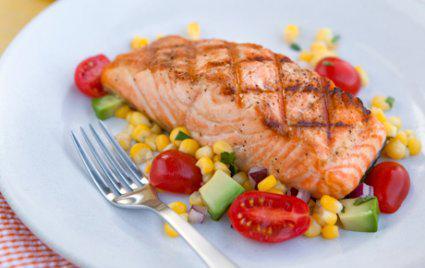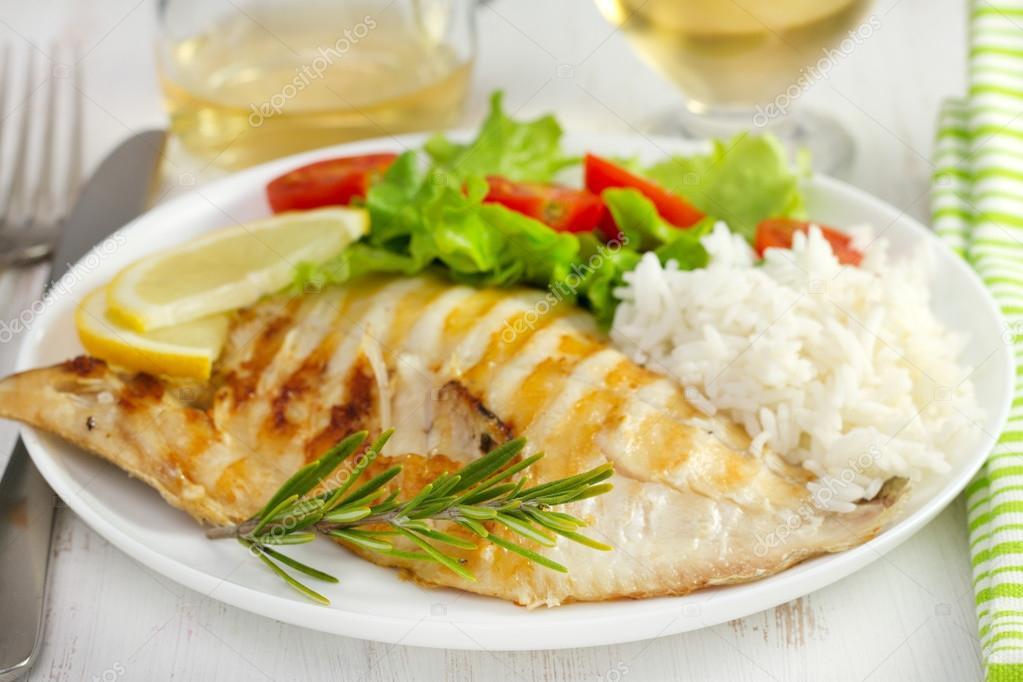The first image is the image on the left, the second image is the image on the right. Given the left and right images, does the statement "One of the entrees is a stack of different layers." hold true? Answer yes or no. No. The first image is the image on the left, the second image is the image on the right. Evaluate the accuracy of this statement regarding the images: "One image shows a vertical stack of at least four 'solid' food items including similar items, and the other image shows a base food item with some other food item on top of it.". Is it true? Answer yes or no. No. 